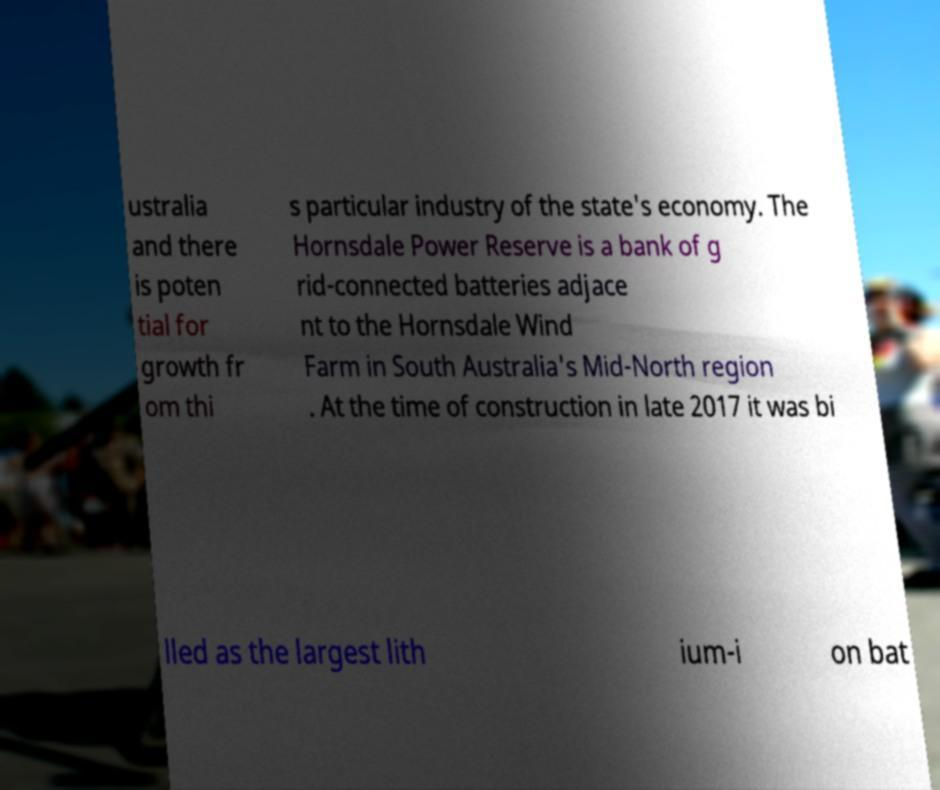Can you read and provide the text displayed in the image?This photo seems to have some interesting text. Can you extract and type it out for me? ustralia and there is poten tial for growth fr om thi s particular industry of the state's economy. The Hornsdale Power Reserve is a bank of g rid-connected batteries adjace nt to the Hornsdale Wind Farm in South Australia's Mid-North region . At the time of construction in late 2017 it was bi lled as the largest lith ium-i on bat 